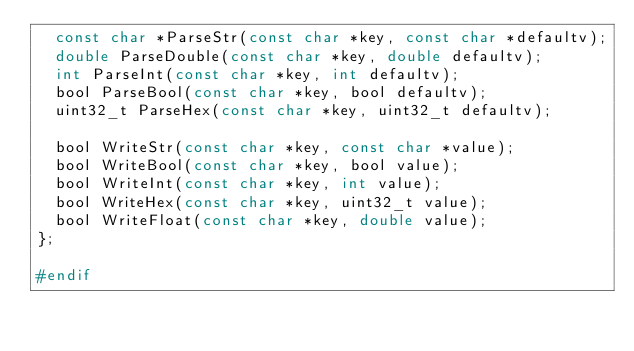<code> <loc_0><loc_0><loc_500><loc_500><_C_>	const char *ParseStr(const char *key, const char *defaultv);
	double ParseDouble(const char *key, double defaultv);
	int ParseInt(const char *key, int defaultv);
	bool ParseBool(const char *key, bool defaultv);
	uint32_t ParseHex(const char *key, uint32_t defaultv);

	bool WriteStr(const char *key, const char *value);
	bool WriteBool(const char *key, bool value);
	bool WriteInt(const char *key, int value);
	bool WriteHex(const char *key, uint32_t value);
	bool WriteFloat(const char *key, double value);
};

#endif
</code> 